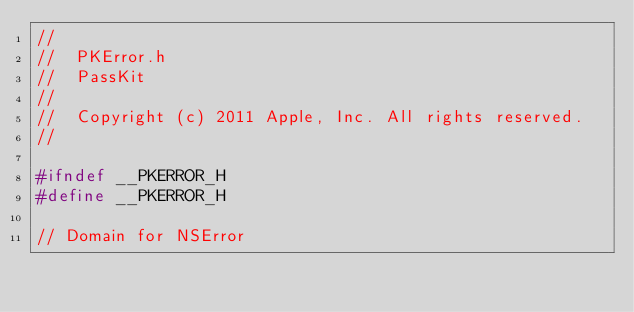Convert code to text. <code><loc_0><loc_0><loc_500><loc_500><_C_>//
//  PKError.h
//  PassKit
//
//  Copyright (c) 2011 Apple, Inc. All rights reserved.
//

#ifndef __PKERROR_H
#define __PKERROR_H

// Domain for NSError</code> 